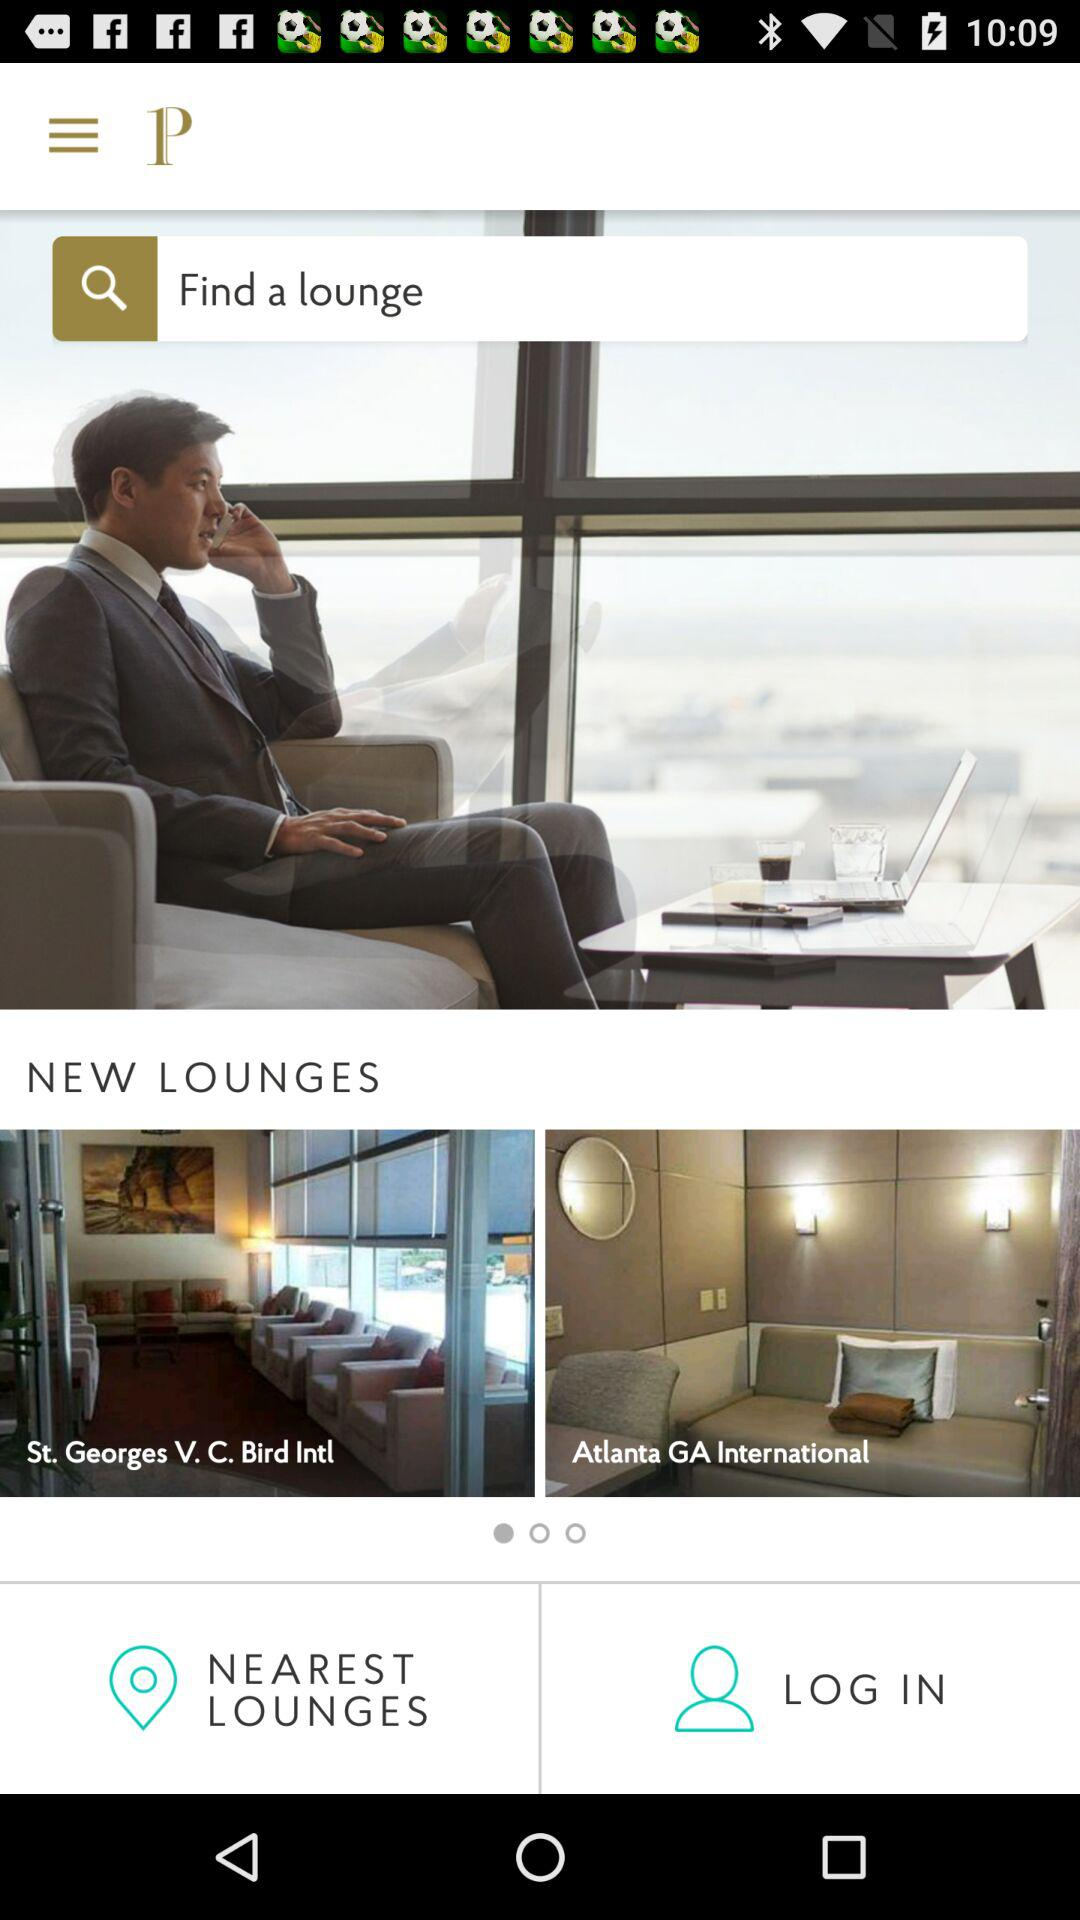What are the names of the new lounges? The names of the new lounges are "St. Georges V. C. Bird Intl" and "Atlanta GA International". 